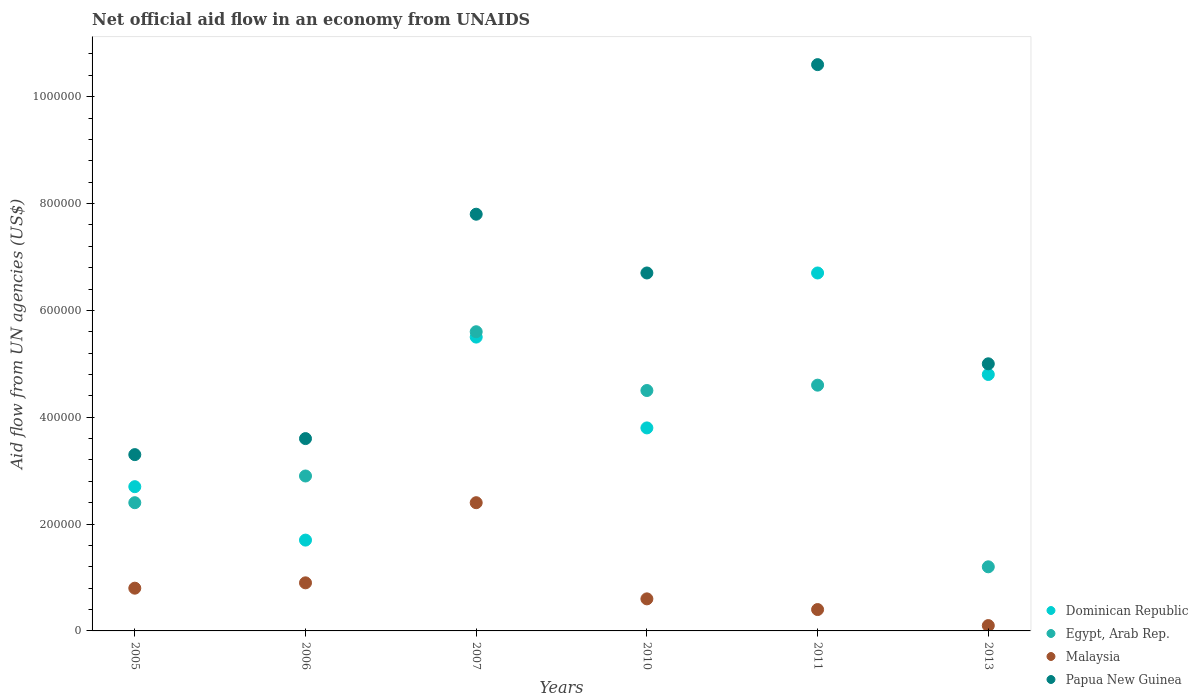Is the number of dotlines equal to the number of legend labels?
Your answer should be compact. Yes. What is the net official aid flow in Papua New Guinea in 2006?
Provide a succinct answer. 3.60e+05. Across all years, what is the maximum net official aid flow in Papua New Guinea?
Keep it short and to the point. 1.06e+06. Across all years, what is the minimum net official aid flow in Egypt, Arab Rep.?
Ensure brevity in your answer.  1.20e+05. In which year was the net official aid flow in Dominican Republic maximum?
Keep it short and to the point. 2011. What is the total net official aid flow in Dominican Republic in the graph?
Your response must be concise. 2.52e+06. What is the difference between the net official aid flow in Egypt, Arab Rep. in 2011 and that in 2013?
Offer a very short reply. 3.40e+05. What is the difference between the net official aid flow in Egypt, Arab Rep. in 2005 and the net official aid flow in Dominican Republic in 2007?
Provide a short and direct response. -3.10e+05. What is the average net official aid flow in Egypt, Arab Rep. per year?
Give a very brief answer. 3.53e+05. In the year 2007, what is the difference between the net official aid flow in Malaysia and net official aid flow in Egypt, Arab Rep.?
Provide a succinct answer. -3.20e+05. What is the ratio of the net official aid flow in Malaysia in 2005 to that in 2010?
Offer a terse response. 1.33. Is the net official aid flow in Egypt, Arab Rep. in 2005 less than that in 2007?
Provide a short and direct response. Yes. Is the difference between the net official aid flow in Malaysia in 2007 and 2011 greater than the difference between the net official aid flow in Egypt, Arab Rep. in 2007 and 2011?
Offer a very short reply. Yes. What is the difference between the highest and the second highest net official aid flow in Papua New Guinea?
Your response must be concise. 2.80e+05. What is the difference between the highest and the lowest net official aid flow in Dominican Republic?
Make the answer very short. 5.00e+05. Is the sum of the net official aid flow in Malaysia in 2011 and 2013 greater than the maximum net official aid flow in Egypt, Arab Rep. across all years?
Offer a very short reply. No. Is it the case that in every year, the sum of the net official aid flow in Dominican Republic and net official aid flow in Papua New Guinea  is greater than the sum of net official aid flow in Malaysia and net official aid flow in Egypt, Arab Rep.?
Provide a short and direct response. No. Is it the case that in every year, the sum of the net official aid flow in Papua New Guinea and net official aid flow in Dominican Republic  is greater than the net official aid flow in Malaysia?
Your answer should be very brief. Yes. Does the net official aid flow in Papua New Guinea monotonically increase over the years?
Provide a short and direct response. No. Is the net official aid flow in Egypt, Arab Rep. strictly less than the net official aid flow in Dominican Republic over the years?
Offer a very short reply. No. How many dotlines are there?
Your answer should be compact. 4. What is the difference between two consecutive major ticks on the Y-axis?
Your answer should be compact. 2.00e+05. Are the values on the major ticks of Y-axis written in scientific E-notation?
Your answer should be very brief. No. Does the graph contain any zero values?
Your answer should be compact. No. Does the graph contain grids?
Provide a succinct answer. No. How many legend labels are there?
Your response must be concise. 4. How are the legend labels stacked?
Make the answer very short. Vertical. What is the title of the graph?
Your answer should be very brief. Net official aid flow in an economy from UNAIDS. What is the label or title of the Y-axis?
Your answer should be compact. Aid flow from UN agencies (US$). What is the Aid flow from UN agencies (US$) in Dominican Republic in 2005?
Make the answer very short. 2.70e+05. What is the Aid flow from UN agencies (US$) of Malaysia in 2005?
Your answer should be compact. 8.00e+04. What is the Aid flow from UN agencies (US$) of Malaysia in 2006?
Make the answer very short. 9.00e+04. What is the Aid flow from UN agencies (US$) of Egypt, Arab Rep. in 2007?
Keep it short and to the point. 5.60e+05. What is the Aid flow from UN agencies (US$) of Papua New Guinea in 2007?
Offer a very short reply. 7.80e+05. What is the Aid flow from UN agencies (US$) in Egypt, Arab Rep. in 2010?
Provide a succinct answer. 4.50e+05. What is the Aid flow from UN agencies (US$) of Malaysia in 2010?
Make the answer very short. 6.00e+04. What is the Aid flow from UN agencies (US$) of Papua New Guinea in 2010?
Give a very brief answer. 6.70e+05. What is the Aid flow from UN agencies (US$) of Dominican Republic in 2011?
Make the answer very short. 6.70e+05. What is the Aid flow from UN agencies (US$) in Papua New Guinea in 2011?
Keep it short and to the point. 1.06e+06. Across all years, what is the maximum Aid flow from UN agencies (US$) in Dominican Republic?
Give a very brief answer. 6.70e+05. Across all years, what is the maximum Aid flow from UN agencies (US$) in Egypt, Arab Rep.?
Ensure brevity in your answer.  5.60e+05. Across all years, what is the maximum Aid flow from UN agencies (US$) in Malaysia?
Your answer should be compact. 2.40e+05. Across all years, what is the maximum Aid flow from UN agencies (US$) of Papua New Guinea?
Your response must be concise. 1.06e+06. Across all years, what is the minimum Aid flow from UN agencies (US$) in Dominican Republic?
Provide a short and direct response. 1.70e+05. Across all years, what is the minimum Aid flow from UN agencies (US$) of Egypt, Arab Rep.?
Provide a short and direct response. 1.20e+05. What is the total Aid flow from UN agencies (US$) in Dominican Republic in the graph?
Provide a short and direct response. 2.52e+06. What is the total Aid flow from UN agencies (US$) in Egypt, Arab Rep. in the graph?
Your answer should be compact. 2.12e+06. What is the total Aid flow from UN agencies (US$) in Malaysia in the graph?
Offer a terse response. 5.20e+05. What is the total Aid flow from UN agencies (US$) of Papua New Guinea in the graph?
Offer a very short reply. 3.70e+06. What is the difference between the Aid flow from UN agencies (US$) in Dominican Republic in 2005 and that in 2006?
Provide a succinct answer. 1.00e+05. What is the difference between the Aid flow from UN agencies (US$) in Dominican Republic in 2005 and that in 2007?
Your answer should be compact. -2.80e+05. What is the difference between the Aid flow from UN agencies (US$) of Egypt, Arab Rep. in 2005 and that in 2007?
Offer a terse response. -3.20e+05. What is the difference between the Aid flow from UN agencies (US$) in Malaysia in 2005 and that in 2007?
Keep it short and to the point. -1.60e+05. What is the difference between the Aid flow from UN agencies (US$) in Papua New Guinea in 2005 and that in 2007?
Your response must be concise. -4.50e+05. What is the difference between the Aid flow from UN agencies (US$) of Egypt, Arab Rep. in 2005 and that in 2010?
Your answer should be very brief. -2.10e+05. What is the difference between the Aid flow from UN agencies (US$) of Malaysia in 2005 and that in 2010?
Keep it short and to the point. 2.00e+04. What is the difference between the Aid flow from UN agencies (US$) of Papua New Guinea in 2005 and that in 2010?
Keep it short and to the point. -3.40e+05. What is the difference between the Aid flow from UN agencies (US$) of Dominican Republic in 2005 and that in 2011?
Provide a short and direct response. -4.00e+05. What is the difference between the Aid flow from UN agencies (US$) in Egypt, Arab Rep. in 2005 and that in 2011?
Your answer should be very brief. -2.20e+05. What is the difference between the Aid flow from UN agencies (US$) in Papua New Guinea in 2005 and that in 2011?
Your answer should be compact. -7.30e+05. What is the difference between the Aid flow from UN agencies (US$) in Dominican Republic in 2006 and that in 2007?
Provide a short and direct response. -3.80e+05. What is the difference between the Aid flow from UN agencies (US$) of Egypt, Arab Rep. in 2006 and that in 2007?
Ensure brevity in your answer.  -2.70e+05. What is the difference between the Aid flow from UN agencies (US$) in Malaysia in 2006 and that in 2007?
Your answer should be compact. -1.50e+05. What is the difference between the Aid flow from UN agencies (US$) in Papua New Guinea in 2006 and that in 2007?
Your response must be concise. -4.20e+05. What is the difference between the Aid flow from UN agencies (US$) in Egypt, Arab Rep. in 2006 and that in 2010?
Ensure brevity in your answer.  -1.60e+05. What is the difference between the Aid flow from UN agencies (US$) in Papua New Guinea in 2006 and that in 2010?
Your answer should be compact. -3.10e+05. What is the difference between the Aid flow from UN agencies (US$) in Dominican Republic in 2006 and that in 2011?
Give a very brief answer. -5.00e+05. What is the difference between the Aid flow from UN agencies (US$) of Egypt, Arab Rep. in 2006 and that in 2011?
Keep it short and to the point. -1.70e+05. What is the difference between the Aid flow from UN agencies (US$) in Malaysia in 2006 and that in 2011?
Give a very brief answer. 5.00e+04. What is the difference between the Aid flow from UN agencies (US$) in Papua New Guinea in 2006 and that in 2011?
Your answer should be very brief. -7.00e+05. What is the difference between the Aid flow from UN agencies (US$) of Dominican Republic in 2006 and that in 2013?
Your response must be concise. -3.10e+05. What is the difference between the Aid flow from UN agencies (US$) of Egypt, Arab Rep. in 2006 and that in 2013?
Your response must be concise. 1.70e+05. What is the difference between the Aid flow from UN agencies (US$) in Dominican Republic in 2007 and that in 2010?
Offer a very short reply. 1.70e+05. What is the difference between the Aid flow from UN agencies (US$) in Egypt, Arab Rep. in 2007 and that in 2010?
Your answer should be very brief. 1.10e+05. What is the difference between the Aid flow from UN agencies (US$) in Malaysia in 2007 and that in 2010?
Offer a very short reply. 1.80e+05. What is the difference between the Aid flow from UN agencies (US$) in Papua New Guinea in 2007 and that in 2010?
Your response must be concise. 1.10e+05. What is the difference between the Aid flow from UN agencies (US$) in Dominican Republic in 2007 and that in 2011?
Keep it short and to the point. -1.20e+05. What is the difference between the Aid flow from UN agencies (US$) of Malaysia in 2007 and that in 2011?
Your answer should be very brief. 2.00e+05. What is the difference between the Aid flow from UN agencies (US$) of Papua New Guinea in 2007 and that in 2011?
Provide a short and direct response. -2.80e+05. What is the difference between the Aid flow from UN agencies (US$) of Dominican Republic in 2007 and that in 2013?
Offer a very short reply. 7.00e+04. What is the difference between the Aid flow from UN agencies (US$) in Egypt, Arab Rep. in 2007 and that in 2013?
Give a very brief answer. 4.40e+05. What is the difference between the Aid flow from UN agencies (US$) of Dominican Republic in 2010 and that in 2011?
Make the answer very short. -2.90e+05. What is the difference between the Aid flow from UN agencies (US$) in Papua New Guinea in 2010 and that in 2011?
Provide a short and direct response. -3.90e+05. What is the difference between the Aid flow from UN agencies (US$) in Dominican Republic in 2011 and that in 2013?
Provide a short and direct response. 1.90e+05. What is the difference between the Aid flow from UN agencies (US$) of Egypt, Arab Rep. in 2011 and that in 2013?
Keep it short and to the point. 3.40e+05. What is the difference between the Aid flow from UN agencies (US$) of Malaysia in 2011 and that in 2013?
Make the answer very short. 3.00e+04. What is the difference between the Aid flow from UN agencies (US$) of Papua New Guinea in 2011 and that in 2013?
Make the answer very short. 5.60e+05. What is the difference between the Aid flow from UN agencies (US$) of Dominican Republic in 2005 and the Aid flow from UN agencies (US$) of Malaysia in 2006?
Provide a succinct answer. 1.80e+05. What is the difference between the Aid flow from UN agencies (US$) of Dominican Republic in 2005 and the Aid flow from UN agencies (US$) of Papua New Guinea in 2006?
Provide a short and direct response. -9.00e+04. What is the difference between the Aid flow from UN agencies (US$) in Malaysia in 2005 and the Aid flow from UN agencies (US$) in Papua New Guinea in 2006?
Ensure brevity in your answer.  -2.80e+05. What is the difference between the Aid flow from UN agencies (US$) in Dominican Republic in 2005 and the Aid flow from UN agencies (US$) in Egypt, Arab Rep. in 2007?
Keep it short and to the point. -2.90e+05. What is the difference between the Aid flow from UN agencies (US$) of Dominican Republic in 2005 and the Aid flow from UN agencies (US$) of Malaysia in 2007?
Provide a short and direct response. 3.00e+04. What is the difference between the Aid flow from UN agencies (US$) of Dominican Republic in 2005 and the Aid flow from UN agencies (US$) of Papua New Guinea in 2007?
Provide a short and direct response. -5.10e+05. What is the difference between the Aid flow from UN agencies (US$) of Egypt, Arab Rep. in 2005 and the Aid flow from UN agencies (US$) of Malaysia in 2007?
Make the answer very short. 0. What is the difference between the Aid flow from UN agencies (US$) in Egypt, Arab Rep. in 2005 and the Aid flow from UN agencies (US$) in Papua New Guinea in 2007?
Keep it short and to the point. -5.40e+05. What is the difference between the Aid flow from UN agencies (US$) of Malaysia in 2005 and the Aid flow from UN agencies (US$) of Papua New Guinea in 2007?
Your answer should be compact. -7.00e+05. What is the difference between the Aid flow from UN agencies (US$) of Dominican Republic in 2005 and the Aid flow from UN agencies (US$) of Egypt, Arab Rep. in 2010?
Your answer should be very brief. -1.80e+05. What is the difference between the Aid flow from UN agencies (US$) of Dominican Republic in 2005 and the Aid flow from UN agencies (US$) of Malaysia in 2010?
Give a very brief answer. 2.10e+05. What is the difference between the Aid flow from UN agencies (US$) of Dominican Republic in 2005 and the Aid flow from UN agencies (US$) of Papua New Guinea in 2010?
Provide a succinct answer. -4.00e+05. What is the difference between the Aid flow from UN agencies (US$) in Egypt, Arab Rep. in 2005 and the Aid flow from UN agencies (US$) in Malaysia in 2010?
Keep it short and to the point. 1.80e+05. What is the difference between the Aid flow from UN agencies (US$) of Egypt, Arab Rep. in 2005 and the Aid flow from UN agencies (US$) of Papua New Guinea in 2010?
Make the answer very short. -4.30e+05. What is the difference between the Aid flow from UN agencies (US$) of Malaysia in 2005 and the Aid flow from UN agencies (US$) of Papua New Guinea in 2010?
Keep it short and to the point. -5.90e+05. What is the difference between the Aid flow from UN agencies (US$) of Dominican Republic in 2005 and the Aid flow from UN agencies (US$) of Malaysia in 2011?
Your answer should be compact. 2.30e+05. What is the difference between the Aid flow from UN agencies (US$) in Dominican Republic in 2005 and the Aid flow from UN agencies (US$) in Papua New Guinea in 2011?
Make the answer very short. -7.90e+05. What is the difference between the Aid flow from UN agencies (US$) in Egypt, Arab Rep. in 2005 and the Aid flow from UN agencies (US$) in Malaysia in 2011?
Ensure brevity in your answer.  2.00e+05. What is the difference between the Aid flow from UN agencies (US$) in Egypt, Arab Rep. in 2005 and the Aid flow from UN agencies (US$) in Papua New Guinea in 2011?
Ensure brevity in your answer.  -8.20e+05. What is the difference between the Aid flow from UN agencies (US$) in Malaysia in 2005 and the Aid flow from UN agencies (US$) in Papua New Guinea in 2011?
Offer a terse response. -9.80e+05. What is the difference between the Aid flow from UN agencies (US$) in Dominican Republic in 2005 and the Aid flow from UN agencies (US$) in Malaysia in 2013?
Keep it short and to the point. 2.60e+05. What is the difference between the Aid flow from UN agencies (US$) in Malaysia in 2005 and the Aid flow from UN agencies (US$) in Papua New Guinea in 2013?
Your response must be concise. -4.20e+05. What is the difference between the Aid flow from UN agencies (US$) of Dominican Republic in 2006 and the Aid flow from UN agencies (US$) of Egypt, Arab Rep. in 2007?
Offer a terse response. -3.90e+05. What is the difference between the Aid flow from UN agencies (US$) in Dominican Republic in 2006 and the Aid flow from UN agencies (US$) in Papua New Guinea in 2007?
Your response must be concise. -6.10e+05. What is the difference between the Aid flow from UN agencies (US$) of Egypt, Arab Rep. in 2006 and the Aid flow from UN agencies (US$) of Malaysia in 2007?
Your response must be concise. 5.00e+04. What is the difference between the Aid flow from UN agencies (US$) in Egypt, Arab Rep. in 2006 and the Aid flow from UN agencies (US$) in Papua New Guinea in 2007?
Provide a short and direct response. -4.90e+05. What is the difference between the Aid flow from UN agencies (US$) of Malaysia in 2006 and the Aid flow from UN agencies (US$) of Papua New Guinea in 2007?
Provide a succinct answer. -6.90e+05. What is the difference between the Aid flow from UN agencies (US$) of Dominican Republic in 2006 and the Aid flow from UN agencies (US$) of Egypt, Arab Rep. in 2010?
Offer a very short reply. -2.80e+05. What is the difference between the Aid flow from UN agencies (US$) of Dominican Republic in 2006 and the Aid flow from UN agencies (US$) of Malaysia in 2010?
Offer a very short reply. 1.10e+05. What is the difference between the Aid flow from UN agencies (US$) in Dominican Republic in 2006 and the Aid flow from UN agencies (US$) in Papua New Guinea in 2010?
Provide a short and direct response. -5.00e+05. What is the difference between the Aid flow from UN agencies (US$) in Egypt, Arab Rep. in 2006 and the Aid flow from UN agencies (US$) in Malaysia in 2010?
Provide a short and direct response. 2.30e+05. What is the difference between the Aid flow from UN agencies (US$) in Egypt, Arab Rep. in 2006 and the Aid flow from UN agencies (US$) in Papua New Guinea in 2010?
Your answer should be compact. -3.80e+05. What is the difference between the Aid flow from UN agencies (US$) of Malaysia in 2006 and the Aid flow from UN agencies (US$) of Papua New Guinea in 2010?
Offer a terse response. -5.80e+05. What is the difference between the Aid flow from UN agencies (US$) of Dominican Republic in 2006 and the Aid flow from UN agencies (US$) of Papua New Guinea in 2011?
Provide a short and direct response. -8.90e+05. What is the difference between the Aid flow from UN agencies (US$) in Egypt, Arab Rep. in 2006 and the Aid flow from UN agencies (US$) in Papua New Guinea in 2011?
Ensure brevity in your answer.  -7.70e+05. What is the difference between the Aid flow from UN agencies (US$) in Malaysia in 2006 and the Aid flow from UN agencies (US$) in Papua New Guinea in 2011?
Offer a very short reply. -9.70e+05. What is the difference between the Aid flow from UN agencies (US$) of Dominican Republic in 2006 and the Aid flow from UN agencies (US$) of Egypt, Arab Rep. in 2013?
Ensure brevity in your answer.  5.00e+04. What is the difference between the Aid flow from UN agencies (US$) in Dominican Republic in 2006 and the Aid flow from UN agencies (US$) in Malaysia in 2013?
Your answer should be compact. 1.60e+05. What is the difference between the Aid flow from UN agencies (US$) in Dominican Republic in 2006 and the Aid flow from UN agencies (US$) in Papua New Guinea in 2013?
Your response must be concise. -3.30e+05. What is the difference between the Aid flow from UN agencies (US$) of Egypt, Arab Rep. in 2006 and the Aid flow from UN agencies (US$) of Malaysia in 2013?
Give a very brief answer. 2.80e+05. What is the difference between the Aid flow from UN agencies (US$) in Malaysia in 2006 and the Aid flow from UN agencies (US$) in Papua New Guinea in 2013?
Keep it short and to the point. -4.10e+05. What is the difference between the Aid flow from UN agencies (US$) of Dominican Republic in 2007 and the Aid flow from UN agencies (US$) of Egypt, Arab Rep. in 2010?
Provide a short and direct response. 1.00e+05. What is the difference between the Aid flow from UN agencies (US$) of Malaysia in 2007 and the Aid flow from UN agencies (US$) of Papua New Guinea in 2010?
Provide a succinct answer. -4.30e+05. What is the difference between the Aid flow from UN agencies (US$) in Dominican Republic in 2007 and the Aid flow from UN agencies (US$) in Egypt, Arab Rep. in 2011?
Ensure brevity in your answer.  9.00e+04. What is the difference between the Aid flow from UN agencies (US$) of Dominican Republic in 2007 and the Aid flow from UN agencies (US$) of Malaysia in 2011?
Offer a very short reply. 5.10e+05. What is the difference between the Aid flow from UN agencies (US$) in Dominican Republic in 2007 and the Aid flow from UN agencies (US$) in Papua New Guinea in 2011?
Offer a terse response. -5.10e+05. What is the difference between the Aid flow from UN agencies (US$) in Egypt, Arab Rep. in 2007 and the Aid flow from UN agencies (US$) in Malaysia in 2011?
Provide a succinct answer. 5.20e+05. What is the difference between the Aid flow from UN agencies (US$) in Egypt, Arab Rep. in 2007 and the Aid flow from UN agencies (US$) in Papua New Guinea in 2011?
Your answer should be very brief. -5.00e+05. What is the difference between the Aid flow from UN agencies (US$) of Malaysia in 2007 and the Aid flow from UN agencies (US$) of Papua New Guinea in 2011?
Your answer should be very brief. -8.20e+05. What is the difference between the Aid flow from UN agencies (US$) in Dominican Republic in 2007 and the Aid flow from UN agencies (US$) in Malaysia in 2013?
Your answer should be very brief. 5.40e+05. What is the difference between the Aid flow from UN agencies (US$) of Dominican Republic in 2007 and the Aid flow from UN agencies (US$) of Papua New Guinea in 2013?
Make the answer very short. 5.00e+04. What is the difference between the Aid flow from UN agencies (US$) in Egypt, Arab Rep. in 2007 and the Aid flow from UN agencies (US$) in Papua New Guinea in 2013?
Make the answer very short. 6.00e+04. What is the difference between the Aid flow from UN agencies (US$) of Dominican Republic in 2010 and the Aid flow from UN agencies (US$) of Malaysia in 2011?
Offer a very short reply. 3.40e+05. What is the difference between the Aid flow from UN agencies (US$) of Dominican Republic in 2010 and the Aid flow from UN agencies (US$) of Papua New Guinea in 2011?
Your answer should be very brief. -6.80e+05. What is the difference between the Aid flow from UN agencies (US$) in Egypt, Arab Rep. in 2010 and the Aid flow from UN agencies (US$) in Malaysia in 2011?
Your answer should be compact. 4.10e+05. What is the difference between the Aid flow from UN agencies (US$) of Egypt, Arab Rep. in 2010 and the Aid flow from UN agencies (US$) of Papua New Guinea in 2011?
Provide a short and direct response. -6.10e+05. What is the difference between the Aid flow from UN agencies (US$) in Dominican Republic in 2010 and the Aid flow from UN agencies (US$) in Malaysia in 2013?
Offer a terse response. 3.70e+05. What is the difference between the Aid flow from UN agencies (US$) of Egypt, Arab Rep. in 2010 and the Aid flow from UN agencies (US$) of Malaysia in 2013?
Provide a short and direct response. 4.40e+05. What is the difference between the Aid flow from UN agencies (US$) of Malaysia in 2010 and the Aid flow from UN agencies (US$) of Papua New Guinea in 2013?
Your answer should be very brief. -4.40e+05. What is the difference between the Aid flow from UN agencies (US$) of Dominican Republic in 2011 and the Aid flow from UN agencies (US$) of Malaysia in 2013?
Ensure brevity in your answer.  6.60e+05. What is the difference between the Aid flow from UN agencies (US$) of Egypt, Arab Rep. in 2011 and the Aid flow from UN agencies (US$) of Papua New Guinea in 2013?
Your response must be concise. -4.00e+04. What is the difference between the Aid flow from UN agencies (US$) in Malaysia in 2011 and the Aid flow from UN agencies (US$) in Papua New Guinea in 2013?
Ensure brevity in your answer.  -4.60e+05. What is the average Aid flow from UN agencies (US$) in Dominican Republic per year?
Your response must be concise. 4.20e+05. What is the average Aid flow from UN agencies (US$) in Egypt, Arab Rep. per year?
Ensure brevity in your answer.  3.53e+05. What is the average Aid flow from UN agencies (US$) of Malaysia per year?
Provide a short and direct response. 8.67e+04. What is the average Aid flow from UN agencies (US$) of Papua New Guinea per year?
Your answer should be very brief. 6.17e+05. In the year 2005, what is the difference between the Aid flow from UN agencies (US$) in Dominican Republic and Aid flow from UN agencies (US$) in Malaysia?
Make the answer very short. 1.90e+05. In the year 2006, what is the difference between the Aid flow from UN agencies (US$) in Dominican Republic and Aid flow from UN agencies (US$) in Egypt, Arab Rep.?
Give a very brief answer. -1.20e+05. In the year 2006, what is the difference between the Aid flow from UN agencies (US$) in Dominican Republic and Aid flow from UN agencies (US$) in Malaysia?
Your answer should be very brief. 8.00e+04. In the year 2006, what is the difference between the Aid flow from UN agencies (US$) of Dominican Republic and Aid flow from UN agencies (US$) of Papua New Guinea?
Provide a short and direct response. -1.90e+05. In the year 2007, what is the difference between the Aid flow from UN agencies (US$) of Dominican Republic and Aid flow from UN agencies (US$) of Egypt, Arab Rep.?
Ensure brevity in your answer.  -10000. In the year 2007, what is the difference between the Aid flow from UN agencies (US$) of Dominican Republic and Aid flow from UN agencies (US$) of Papua New Guinea?
Offer a very short reply. -2.30e+05. In the year 2007, what is the difference between the Aid flow from UN agencies (US$) of Egypt, Arab Rep. and Aid flow from UN agencies (US$) of Malaysia?
Your answer should be compact. 3.20e+05. In the year 2007, what is the difference between the Aid flow from UN agencies (US$) in Malaysia and Aid flow from UN agencies (US$) in Papua New Guinea?
Your response must be concise. -5.40e+05. In the year 2010, what is the difference between the Aid flow from UN agencies (US$) in Dominican Republic and Aid flow from UN agencies (US$) in Egypt, Arab Rep.?
Your response must be concise. -7.00e+04. In the year 2010, what is the difference between the Aid flow from UN agencies (US$) of Dominican Republic and Aid flow from UN agencies (US$) of Malaysia?
Your answer should be very brief. 3.20e+05. In the year 2010, what is the difference between the Aid flow from UN agencies (US$) in Egypt, Arab Rep. and Aid flow from UN agencies (US$) in Malaysia?
Offer a very short reply. 3.90e+05. In the year 2010, what is the difference between the Aid flow from UN agencies (US$) of Malaysia and Aid flow from UN agencies (US$) of Papua New Guinea?
Offer a terse response. -6.10e+05. In the year 2011, what is the difference between the Aid flow from UN agencies (US$) in Dominican Republic and Aid flow from UN agencies (US$) in Egypt, Arab Rep.?
Offer a very short reply. 2.10e+05. In the year 2011, what is the difference between the Aid flow from UN agencies (US$) in Dominican Republic and Aid flow from UN agencies (US$) in Malaysia?
Keep it short and to the point. 6.30e+05. In the year 2011, what is the difference between the Aid flow from UN agencies (US$) of Dominican Republic and Aid flow from UN agencies (US$) of Papua New Guinea?
Make the answer very short. -3.90e+05. In the year 2011, what is the difference between the Aid flow from UN agencies (US$) in Egypt, Arab Rep. and Aid flow from UN agencies (US$) in Papua New Guinea?
Give a very brief answer. -6.00e+05. In the year 2011, what is the difference between the Aid flow from UN agencies (US$) in Malaysia and Aid flow from UN agencies (US$) in Papua New Guinea?
Your answer should be very brief. -1.02e+06. In the year 2013, what is the difference between the Aid flow from UN agencies (US$) of Dominican Republic and Aid flow from UN agencies (US$) of Egypt, Arab Rep.?
Offer a terse response. 3.60e+05. In the year 2013, what is the difference between the Aid flow from UN agencies (US$) in Dominican Republic and Aid flow from UN agencies (US$) in Papua New Guinea?
Make the answer very short. -2.00e+04. In the year 2013, what is the difference between the Aid flow from UN agencies (US$) of Egypt, Arab Rep. and Aid flow from UN agencies (US$) of Papua New Guinea?
Provide a succinct answer. -3.80e+05. In the year 2013, what is the difference between the Aid flow from UN agencies (US$) of Malaysia and Aid flow from UN agencies (US$) of Papua New Guinea?
Your answer should be very brief. -4.90e+05. What is the ratio of the Aid flow from UN agencies (US$) of Dominican Republic in 2005 to that in 2006?
Provide a succinct answer. 1.59. What is the ratio of the Aid flow from UN agencies (US$) in Egypt, Arab Rep. in 2005 to that in 2006?
Give a very brief answer. 0.83. What is the ratio of the Aid flow from UN agencies (US$) in Papua New Guinea in 2005 to that in 2006?
Offer a very short reply. 0.92. What is the ratio of the Aid flow from UN agencies (US$) in Dominican Republic in 2005 to that in 2007?
Provide a short and direct response. 0.49. What is the ratio of the Aid flow from UN agencies (US$) in Egypt, Arab Rep. in 2005 to that in 2007?
Your response must be concise. 0.43. What is the ratio of the Aid flow from UN agencies (US$) in Papua New Guinea in 2005 to that in 2007?
Keep it short and to the point. 0.42. What is the ratio of the Aid flow from UN agencies (US$) in Dominican Republic in 2005 to that in 2010?
Keep it short and to the point. 0.71. What is the ratio of the Aid flow from UN agencies (US$) of Egypt, Arab Rep. in 2005 to that in 2010?
Your answer should be very brief. 0.53. What is the ratio of the Aid flow from UN agencies (US$) of Papua New Guinea in 2005 to that in 2010?
Provide a short and direct response. 0.49. What is the ratio of the Aid flow from UN agencies (US$) in Dominican Republic in 2005 to that in 2011?
Offer a very short reply. 0.4. What is the ratio of the Aid flow from UN agencies (US$) of Egypt, Arab Rep. in 2005 to that in 2011?
Offer a very short reply. 0.52. What is the ratio of the Aid flow from UN agencies (US$) in Malaysia in 2005 to that in 2011?
Your answer should be compact. 2. What is the ratio of the Aid flow from UN agencies (US$) in Papua New Guinea in 2005 to that in 2011?
Your answer should be compact. 0.31. What is the ratio of the Aid flow from UN agencies (US$) of Dominican Republic in 2005 to that in 2013?
Your response must be concise. 0.56. What is the ratio of the Aid flow from UN agencies (US$) in Malaysia in 2005 to that in 2013?
Give a very brief answer. 8. What is the ratio of the Aid flow from UN agencies (US$) in Papua New Guinea in 2005 to that in 2013?
Offer a terse response. 0.66. What is the ratio of the Aid flow from UN agencies (US$) in Dominican Republic in 2006 to that in 2007?
Make the answer very short. 0.31. What is the ratio of the Aid flow from UN agencies (US$) of Egypt, Arab Rep. in 2006 to that in 2007?
Offer a terse response. 0.52. What is the ratio of the Aid flow from UN agencies (US$) in Papua New Guinea in 2006 to that in 2007?
Provide a short and direct response. 0.46. What is the ratio of the Aid flow from UN agencies (US$) in Dominican Republic in 2006 to that in 2010?
Give a very brief answer. 0.45. What is the ratio of the Aid flow from UN agencies (US$) in Egypt, Arab Rep. in 2006 to that in 2010?
Your answer should be compact. 0.64. What is the ratio of the Aid flow from UN agencies (US$) in Malaysia in 2006 to that in 2010?
Provide a succinct answer. 1.5. What is the ratio of the Aid flow from UN agencies (US$) in Papua New Guinea in 2006 to that in 2010?
Keep it short and to the point. 0.54. What is the ratio of the Aid flow from UN agencies (US$) in Dominican Republic in 2006 to that in 2011?
Make the answer very short. 0.25. What is the ratio of the Aid flow from UN agencies (US$) in Egypt, Arab Rep. in 2006 to that in 2011?
Your answer should be very brief. 0.63. What is the ratio of the Aid flow from UN agencies (US$) of Malaysia in 2006 to that in 2011?
Provide a succinct answer. 2.25. What is the ratio of the Aid flow from UN agencies (US$) in Papua New Guinea in 2006 to that in 2011?
Keep it short and to the point. 0.34. What is the ratio of the Aid flow from UN agencies (US$) in Dominican Republic in 2006 to that in 2013?
Provide a short and direct response. 0.35. What is the ratio of the Aid flow from UN agencies (US$) of Egypt, Arab Rep. in 2006 to that in 2013?
Give a very brief answer. 2.42. What is the ratio of the Aid flow from UN agencies (US$) of Malaysia in 2006 to that in 2013?
Your answer should be very brief. 9. What is the ratio of the Aid flow from UN agencies (US$) in Papua New Guinea in 2006 to that in 2013?
Offer a terse response. 0.72. What is the ratio of the Aid flow from UN agencies (US$) of Dominican Republic in 2007 to that in 2010?
Provide a short and direct response. 1.45. What is the ratio of the Aid flow from UN agencies (US$) of Egypt, Arab Rep. in 2007 to that in 2010?
Offer a terse response. 1.24. What is the ratio of the Aid flow from UN agencies (US$) in Malaysia in 2007 to that in 2010?
Provide a short and direct response. 4. What is the ratio of the Aid flow from UN agencies (US$) of Papua New Guinea in 2007 to that in 2010?
Keep it short and to the point. 1.16. What is the ratio of the Aid flow from UN agencies (US$) of Dominican Republic in 2007 to that in 2011?
Provide a short and direct response. 0.82. What is the ratio of the Aid flow from UN agencies (US$) in Egypt, Arab Rep. in 2007 to that in 2011?
Your response must be concise. 1.22. What is the ratio of the Aid flow from UN agencies (US$) in Malaysia in 2007 to that in 2011?
Provide a short and direct response. 6. What is the ratio of the Aid flow from UN agencies (US$) of Papua New Guinea in 2007 to that in 2011?
Keep it short and to the point. 0.74. What is the ratio of the Aid flow from UN agencies (US$) in Dominican Republic in 2007 to that in 2013?
Ensure brevity in your answer.  1.15. What is the ratio of the Aid flow from UN agencies (US$) of Egypt, Arab Rep. in 2007 to that in 2013?
Your answer should be compact. 4.67. What is the ratio of the Aid flow from UN agencies (US$) in Papua New Guinea in 2007 to that in 2013?
Make the answer very short. 1.56. What is the ratio of the Aid flow from UN agencies (US$) of Dominican Republic in 2010 to that in 2011?
Your response must be concise. 0.57. What is the ratio of the Aid flow from UN agencies (US$) in Egypt, Arab Rep. in 2010 to that in 2011?
Offer a very short reply. 0.98. What is the ratio of the Aid flow from UN agencies (US$) in Malaysia in 2010 to that in 2011?
Provide a short and direct response. 1.5. What is the ratio of the Aid flow from UN agencies (US$) in Papua New Guinea in 2010 to that in 2011?
Offer a terse response. 0.63. What is the ratio of the Aid flow from UN agencies (US$) of Dominican Republic in 2010 to that in 2013?
Keep it short and to the point. 0.79. What is the ratio of the Aid flow from UN agencies (US$) of Egypt, Arab Rep. in 2010 to that in 2013?
Provide a short and direct response. 3.75. What is the ratio of the Aid flow from UN agencies (US$) of Papua New Guinea in 2010 to that in 2013?
Provide a short and direct response. 1.34. What is the ratio of the Aid flow from UN agencies (US$) in Dominican Republic in 2011 to that in 2013?
Keep it short and to the point. 1.4. What is the ratio of the Aid flow from UN agencies (US$) of Egypt, Arab Rep. in 2011 to that in 2013?
Provide a succinct answer. 3.83. What is the ratio of the Aid flow from UN agencies (US$) of Malaysia in 2011 to that in 2013?
Ensure brevity in your answer.  4. What is the ratio of the Aid flow from UN agencies (US$) of Papua New Guinea in 2011 to that in 2013?
Your response must be concise. 2.12. What is the difference between the highest and the second highest Aid flow from UN agencies (US$) of Egypt, Arab Rep.?
Your response must be concise. 1.00e+05. What is the difference between the highest and the second highest Aid flow from UN agencies (US$) in Malaysia?
Your answer should be compact. 1.50e+05. What is the difference between the highest and the lowest Aid flow from UN agencies (US$) in Egypt, Arab Rep.?
Your answer should be very brief. 4.40e+05. What is the difference between the highest and the lowest Aid flow from UN agencies (US$) of Malaysia?
Your response must be concise. 2.30e+05. What is the difference between the highest and the lowest Aid flow from UN agencies (US$) in Papua New Guinea?
Provide a succinct answer. 7.30e+05. 